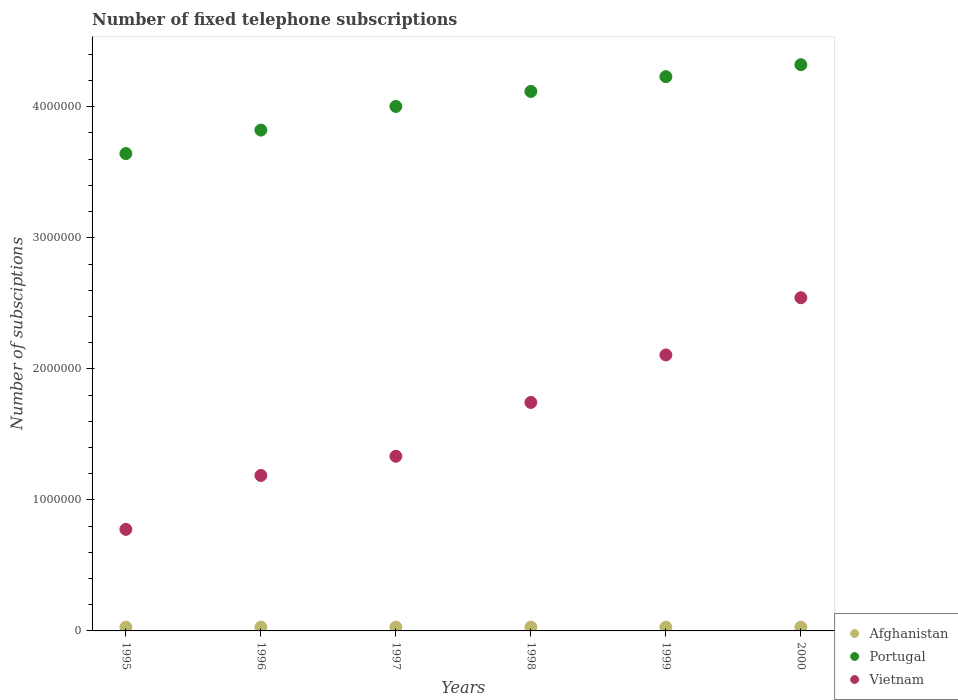How many different coloured dotlines are there?
Ensure brevity in your answer.  3. What is the number of fixed telephone subscriptions in Afghanistan in 1997?
Provide a succinct answer. 2.90e+04. Across all years, what is the maximum number of fixed telephone subscriptions in Vietnam?
Keep it short and to the point. 2.54e+06. Across all years, what is the minimum number of fixed telephone subscriptions in Vietnam?
Provide a short and direct response. 7.75e+05. What is the total number of fixed telephone subscriptions in Portugal in the graph?
Offer a terse response. 2.41e+07. What is the difference between the number of fixed telephone subscriptions in Portugal in 1996 and that in 1999?
Keep it short and to the point. -4.08e+05. What is the difference between the number of fixed telephone subscriptions in Portugal in 1998 and the number of fixed telephone subscriptions in Vietnam in 2000?
Make the answer very short. 1.57e+06. What is the average number of fixed telephone subscriptions in Afghanistan per year?
Provide a short and direct response. 2.90e+04. In the year 1998, what is the difference between the number of fixed telephone subscriptions in Portugal and number of fixed telephone subscriptions in Vietnam?
Ensure brevity in your answer.  2.37e+06. In how many years, is the number of fixed telephone subscriptions in Afghanistan greater than 1800000?
Provide a succinct answer. 0. What is the ratio of the number of fixed telephone subscriptions in Vietnam in 1995 to that in 2000?
Give a very brief answer. 0.3. Is the difference between the number of fixed telephone subscriptions in Portugal in 1998 and 1999 greater than the difference between the number of fixed telephone subscriptions in Vietnam in 1998 and 1999?
Offer a terse response. Yes. What is the difference between the highest and the second highest number of fixed telephone subscriptions in Vietnam?
Your response must be concise. 4.37e+05. What is the difference between the highest and the lowest number of fixed telephone subscriptions in Afghanistan?
Your response must be concise. 0. Is the sum of the number of fixed telephone subscriptions in Afghanistan in 1997 and 2000 greater than the maximum number of fixed telephone subscriptions in Vietnam across all years?
Your answer should be very brief. No. Is it the case that in every year, the sum of the number of fixed telephone subscriptions in Portugal and number of fixed telephone subscriptions in Afghanistan  is greater than the number of fixed telephone subscriptions in Vietnam?
Ensure brevity in your answer.  Yes. Is the number of fixed telephone subscriptions in Afghanistan strictly greater than the number of fixed telephone subscriptions in Vietnam over the years?
Give a very brief answer. No. Is the number of fixed telephone subscriptions in Portugal strictly less than the number of fixed telephone subscriptions in Afghanistan over the years?
Make the answer very short. No. How many years are there in the graph?
Make the answer very short. 6. Does the graph contain any zero values?
Ensure brevity in your answer.  No. Does the graph contain grids?
Your answer should be very brief. No. How many legend labels are there?
Offer a terse response. 3. What is the title of the graph?
Provide a succinct answer. Number of fixed telephone subscriptions. Does "Myanmar" appear as one of the legend labels in the graph?
Offer a very short reply. No. What is the label or title of the Y-axis?
Provide a short and direct response. Number of subsciptions. What is the Number of subsciptions in Afghanistan in 1995?
Your response must be concise. 2.90e+04. What is the Number of subsciptions of Portugal in 1995?
Offer a very short reply. 3.64e+06. What is the Number of subsciptions in Vietnam in 1995?
Ensure brevity in your answer.  7.75e+05. What is the Number of subsciptions in Afghanistan in 1996?
Keep it short and to the point. 2.90e+04. What is the Number of subsciptions in Portugal in 1996?
Offer a terse response. 3.82e+06. What is the Number of subsciptions of Vietnam in 1996?
Your answer should be compact. 1.19e+06. What is the Number of subsciptions in Afghanistan in 1997?
Your response must be concise. 2.90e+04. What is the Number of subsciptions of Portugal in 1997?
Your response must be concise. 4.00e+06. What is the Number of subsciptions in Vietnam in 1997?
Your response must be concise. 1.33e+06. What is the Number of subsciptions in Afghanistan in 1998?
Offer a very short reply. 2.90e+04. What is the Number of subsciptions of Portugal in 1998?
Provide a short and direct response. 4.12e+06. What is the Number of subsciptions in Vietnam in 1998?
Give a very brief answer. 1.74e+06. What is the Number of subsciptions in Afghanistan in 1999?
Your answer should be compact. 2.90e+04. What is the Number of subsciptions of Portugal in 1999?
Offer a terse response. 4.23e+06. What is the Number of subsciptions in Vietnam in 1999?
Provide a succinct answer. 2.11e+06. What is the Number of subsciptions of Afghanistan in 2000?
Your response must be concise. 2.90e+04. What is the Number of subsciptions in Portugal in 2000?
Offer a very short reply. 4.32e+06. What is the Number of subsciptions in Vietnam in 2000?
Give a very brief answer. 2.54e+06. Across all years, what is the maximum Number of subsciptions of Afghanistan?
Provide a short and direct response. 2.90e+04. Across all years, what is the maximum Number of subsciptions of Portugal?
Give a very brief answer. 4.32e+06. Across all years, what is the maximum Number of subsciptions of Vietnam?
Provide a short and direct response. 2.54e+06. Across all years, what is the minimum Number of subsciptions of Afghanistan?
Ensure brevity in your answer.  2.90e+04. Across all years, what is the minimum Number of subsciptions of Portugal?
Your response must be concise. 3.64e+06. Across all years, what is the minimum Number of subsciptions in Vietnam?
Provide a succinct answer. 7.75e+05. What is the total Number of subsciptions in Afghanistan in the graph?
Provide a succinct answer. 1.74e+05. What is the total Number of subsciptions in Portugal in the graph?
Your answer should be compact. 2.41e+07. What is the total Number of subsciptions in Vietnam in the graph?
Give a very brief answer. 9.69e+06. What is the difference between the Number of subsciptions of Portugal in 1995 and that in 1996?
Provide a succinct answer. -1.79e+05. What is the difference between the Number of subsciptions of Vietnam in 1995 and that in 1996?
Offer a terse response. -4.11e+05. What is the difference between the Number of subsciptions in Afghanistan in 1995 and that in 1997?
Your response must be concise. 0. What is the difference between the Number of subsciptions in Portugal in 1995 and that in 1997?
Your answer should be very brief. -3.60e+05. What is the difference between the Number of subsciptions in Vietnam in 1995 and that in 1997?
Your answer should be compact. -5.58e+05. What is the difference between the Number of subsciptions in Portugal in 1995 and that in 1998?
Give a very brief answer. -4.74e+05. What is the difference between the Number of subsciptions of Vietnam in 1995 and that in 1998?
Your answer should be very brief. -9.69e+05. What is the difference between the Number of subsciptions in Portugal in 1995 and that in 1999?
Offer a very short reply. -5.87e+05. What is the difference between the Number of subsciptions of Vietnam in 1995 and that in 1999?
Offer a terse response. -1.33e+06. What is the difference between the Number of subsciptions in Afghanistan in 1995 and that in 2000?
Ensure brevity in your answer.  0. What is the difference between the Number of subsciptions of Portugal in 1995 and that in 2000?
Ensure brevity in your answer.  -6.78e+05. What is the difference between the Number of subsciptions in Vietnam in 1995 and that in 2000?
Provide a short and direct response. -1.77e+06. What is the difference between the Number of subsciptions in Afghanistan in 1996 and that in 1997?
Provide a succinct answer. 0. What is the difference between the Number of subsciptions of Portugal in 1996 and that in 1997?
Ensure brevity in your answer.  -1.81e+05. What is the difference between the Number of subsciptions in Vietnam in 1996 and that in 1997?
Ensure brevity in your answer.  -1.47e+05. What is the difference between the Number of subsciptions of Portugal in 1996 and that in 1998?
Your response must be concise. -2.95e+05. What is the difference between the Number of subsciptions of Vietnam in 1996 and that in 1998?
Provide a short and direct response. -5.57e+05. What is the difference between the Number of subsciptions in Portugal in 1996 and that in 1999?
Keep it short and to the point. -4.08e+05. What is the difference between the Number of subsciptions in Vietnam in 1996 and that in 1999?
Offer a terse response. -9.20e+05. What is the difference between the Number of subsciptions in Portugal in 1996 and that in 2000?
Your answer should be compact. -4.99e+05. What is the difference between the Number of subsciptions in Vietnam in 1996 and that in 2000?
Give a very brief answer. -1.36e+06. What is the difference between the Number of subsciptions of Portugal in 1997 and that in 1998?
Offer a terse response. -1.14e+05. What is the difference between the Number of subsciptions in Vietnam in 1997 and that in 1998?
Keep it short and to the point. -4.11e+05. What is the difference between the Number of subsciptions in Portugal in 1997 and that in 1999?
Make the answer very short. -2.27e+05. What is the difference between the Number of subsciptions of Vietnam in 1997 and that in 1999?
Ensure brevity in your answer.  -7.73e+05. What is the difference between the Number of subsciptions in Afghanistan in 1997 and that in 2000?
Your answer should be very brief. 0. What is the difference between the Number of subsciptions in Portugal in 1997 and that in 2000?
Provide a short and direct response. -3.19e+05. What is the difference between the Number of subsciptions in Vietnam in 1997 and that in 2000?
Provide a short and direct response. -1.21e+06. What is the difference between the Number of subsciptions in Portugal in 1998 and that in 1999?
Ensure brevity in your answer.  -1.13e+05. What is the difference between the Number of subsciptions of Vietnam in 1998 and that in 1999?
Make the answer very short. -3.62e+05. What is the difference between the Number of subsciptions in Portugal in 1998 and that in 2000?
Your response must be concise. -2.04e+05. What is the difference between the Number of subsciptions in Vietnam in 1998 and that in 2000?
Your answer should be very brief. -7.99e+05. What is the difference between the Number of subsciptions of Afghanistan in 1999 and that in 2000?
Provide a succinct answer. 0. What is the difference between the Number of subsciptions in Portugal in 1999 and that in 2000?
Your answer should be compact. -9.12e+04. What is the difference between the Number of subsciptions in Vietnam in 1999 and that in 2000?
Ensure brevity in your answer.  -4.37e+05. What is the difference between the Number of subsciptions in Afghanistan in 1995 and the Number of subsciptions in Portugal in 1996?
Provide a succinct answer. -3.79e+06. What is the difference between the Number of subsciptions in Afghanistan in 1995 and the Number of subsciptions in Vietnam in 1996?
Offer a terse response. -1.16e+06. What is the difference between the Number of subsciptions of Portugal in 1995 and the Number of subsciptions of Vietnam in 1996?
Keep it short and to the point. 2.46e+06. What is the difference between the Number of subsciptions of Afghanistan in 1995 and the Number of subsciptions of Portugal in 1997?
Your answer should be compact. -3.97e+06. What is the difference between the Number of subsciptions in Afghanistan in 1995 and the Number of subsciptions in Vietnam in 1997?
Provide a short and direct response. -1.30e+06. What is the difference between the Number of subsciptions of Portugal in 1995 and the Number of subsciptions of Vietnam in 1997?
Your response must be concise. 2.31e+06. What is the difference between the Number of subsciptions in Afghanistan in 1995 and the Number of subsciptions in Portugal in 1998?
Provide a succinct answer. -4.09e+06. What is the difference between the Number of subsciptions of Afghanistan in 1995 and the Number of subsciptions of Vietnam in 1998?
Give a very brief answer. -1.71e+06. What is the difference between the Number of subsciptions in Portugal in 1995 and the Number of subsciptions in Vietnam in 1998?
Your response must be concise. 1.90e+06. What is the difference between the Number of subsciptions of Afghanistan in 1995 and the Number of subsciptions of Portugal in 1999?
Your answer should be very brief. -4.20e+06. What is the difference between the Number of subsciptions in Afghanistan in 1995 and the Number of subsciptions in Vietnam in 1999?
Provide a short and direct response. -2.08e+06. What is the difference between the Number of subsciptions of Portugal in 1995 and the Number of subsciptions of Vietnam in 1999?
Your answer should be compact. 1.54e+06. What is the difference between the Number of subsciptions of Afghanistan in 1995 and the Number of subsciptions of Portugal in 2000?
Your answer should be very brief. -4.29e+06. What is the difference between the Number of subsciptions in Afghanistan in 1995 and the Number of subsciptions in Vietnam in 2000?
Give a very brief answer. -2.51e+06. What is the difference between the Number of subsciptions of Portugal in 1995 and the Number of subsciptions of Vietnam in 2000?
Make the answer very short. 1.10e+06. What is the difference between the Number of subsciptions of Afghanistan in 1996 and the Number of subsciptions of Portugal in 1997?
Provide a short and direct response. -3.97e+06. What is the difference between the Number of subsciptions in Afghanistan in 1996 and the Number of subsciptions in Vietnam in 1997?
Ensure brevity in your answer.  -1.30e+06. What is the difference between the Number of subsciptions in Portugal in 1996 and the Number of subsciptions in Vietnam in 1997?
Provide a short and direct response. 2.49e+06. What is the difference between the Number of subsciptions of Afghanistan in 1996 and the Number of subsciptions of Portugal in 1998?
Your answer should be compact. -4.09e+06. What is the difference between the Number of subsciptions in Afghanistan in 1996 and the Number of subsciptions in Vietnam in 1998?
Your response must be concise. -1.71e+06. What is the difference between the Number of subsciptions in Portugal in 1996 and the Number of subsciptions in Vietnam in 1998?
Your response must be concise. 2.08e+06. What is the difference between the Number of subsciptions in Afghanistan in 1996 and the Number of subsciptions in Portugal in 1999?
Your response must be concise. -4.20e+06. What is the difference between the Number of subsciptions of Afghanistan in 1996 and the Number of subsciptions of Vietnam in 1999?
Give a very brief answer. -2.08e+06. What is the difference between the Number of subsciptions in Portugal in 1996 and the Number of subsciptions in Vietnam in 1999?
Offer a very short reply. 1.72e+06. What is the difference between the Number of subsciptions of Afghanistan in 1996 and the Number of subsciptions of Portugal in 2000?
Offer a very short reply. -4.29e+06. What is the difference between the Number of subsciptions in Afghanistan in 1996 and the Number of subsciptions in Vietnam in 2000?
Give a very brief answer. -2.51e+06. What is the difference between the Number of subsciptions in Portugal in 1996 and the Number of subsciptions in Vietnam in 2000?
Provide a short and direct response. 1.28e+06. What is the difference between the Number of subsciptions of Afghanistan in 1997 and the Number of subsciptions of Portugal in 1998?
Provide a short and direct response. -4.09e+06. What is the difference between the Number of subsciptions in Afghanistan in 1997 and the Number of subsciptions in Vietnam in 1998?
Offer a terse response. -1.71e+06. What is the difference between the Number of subsciptions of Portugal in 1997 and the Number of subsciptions of Vietnam in 1998?
Make the answer very short. 2.26e+06. What is the difference between the Number of subsciptions in Afghanistan in 1997 and the Number of subsciptions in Portugal in 1999?
Provide a succinct answer. -4.20e+06. What is the difference between the Number of subsciptions in Afghanistan in 1997 and the Number of subsciptions in Vietnam in 1999?
Offer a terse response. -2.08e+06. What is the difference between the Number of subsciptions of Portugal in 1997 and the Number of subsciptions of Vietnam in 1999?
Give a very brief answer. 1.90e+06. What is the difference between the Number of subsciptions of Afghanistan in 1997 and the Number of subsciptions of Portugal in 2000?
Ensure brevity in your answer.  -4.29e+06. What is the difference between the Number of subsciptions in Afghanistan in 1997 and the Number of subsciptions in Vietnam in 2000?
Your response must be concise. -2.51e+06. What is the difference between the Number of subsciptions in Portugal in 1997 and the Number of subsciptions in Vietnam in 2000?
Ensure brevity in your answer.  1.46e+06. What is the difference between the Number of subsciptions in Afghanistan in 1998 and the Number of subsciptions in Portugal in 1999?
Provide a succinct answer. -4.20e+06. What is the difference between the Number of subsciptions of Afghanistan in 1998 and the Number of subsciptions of Vietnam in 1999?
Your answer should be very brief. -2.08e+06. What is the difference between the Number of subsciptions of Portugal in 1998 and the Number of subsciptions of Vietnam in 1999?
Give a very brief answer. 2.01e+06. What is the difference between the Number of subsciptions in Afghanistan in 1998 and the Number of subsciptions in Portugal in 2000?
Give a very brief answer. -4.29e+06. What is the difference between the Number of subsciptions in Afghanistan in 1998 and the Number of subsciptions in Vietnam in 2000?
Keep it short and to the point. -2.51e+06. What is the difference between the Number of subsciptions of Portugal in 1998 and the Number of subsciptions of Vietnam in 2000?
Give a very brief answer. 1.57e+06. What is the difference between the Number of subsciptions in Afghanistan in 1999 and the Number of subsciptions in Portugal in 2000?
Provide a succinct answer. -4.29e+06. What is the difference between the Number of subsciptions of Afghanistan in 1999 and the Number of subsciptions of Vietnam in 2000?
Offer a very short reply. -2.51e+06. What is the difference between the Number of subsciptions of Portugal in 1999 and the Number of subsciptions of Vietnam in 2000?
Your response must be concise. 1.69e+06. What is the average Number of subsciptions of Afghanistan per year?
Provide a short and direct response. 2.90e+04. What is the average Number of subsciptions in Portugal per year?
Your answer should be compact. 4.02e+06. What is the average Number of subsciptions of Vietnam per year?
Make the answer very short. 1.61e+06. In the year 1995, what is the difference between the Number of subsciptions in Afghanistan and Number of subsciptions in Portugal?
Offer a terse response. -3.61e+06. In the year 1995, what is the difference between the Number of subsciptions in Afghanistan and Number of subsciptions in Vietnam?
Provide a succinct answer. -7.46e+05. In the year 1995, what is the difference between the Number of subsciptions in Portugal and Number of subsciptions in Vietnam?
Give a very brief answer. 2.87e+06. In the year 1996, what is the difference between the Number of subsciptions of Afghanistan and Number of subsciptions of Portugal?
Offer a terse response. -3.79e+06. In the year 1996, what is the difference between the Number of subsciptions in Afghanistan and Number of subsciptions in Vietnam?
Provide a succinct answer. -1.16e+06. In the year 1996, what is the difference between the Number of subsciptions of Portugal and Number of subsciptions of Vietnam?
Provide a short and direct response. 2.64e+06. In the year 1997, what is the difference between the Number of subsciptions in Afghanistan and Number of subsciptions in Portugal?
Provide a short and direct response. -3.97e+06. In the year 1997, what is the difference between the Number of subsciptions in Afghanistan and Number of subsciptions in Vietnam?
Your answer should be compact. -1.30e+06. In the year 1997, what is the difference between the Number of subsciptions of Portugal and Number of subsciptions of Vietnam?
Your answer should be compact. 2.67e+06. In the year 1998, what is the difference between the Number of subsciptions in Afghanistan and Number of subsciptions in Portugal?
Make the answer very short. -4.09e+06. In the year 1998, what is the difference between the Number of subsciptions of Afghanistan and Number of subsciptions of Vietnam?
Give a very brief answer. -1.71e+06. In the year 1998, what is the difference between the Number of subsciptions in Portugal and Number of subsciptions in Vietnam?
Your response must be concise. 2.37e+06. In the year 1999, what is the difference between the Number of subsciptions of Afghanistan and Number of subsciptions of Portugal?
Provide a succinct answer. -4.20e+06. In the year 1999, what is the difference between the Number of subsciptions of Afghanistan and Number of subsciptions of Vietnam?
Your answer should be compact. -2.08e+06. In the year 1999, what is the difference between the Number of subsciptions of Portugal and Number of subsciptions of Vietnam?
Provide a succinct answer. 2.12e+06. In the year 2000, what is the difference between the Number of subsciptions in Afghanistan and Number of subsciptions in Portugal?
Your answer should be compact. -4.29e+06. In the year 2000, what is the difference between the Number of subsciptions in Afghanistan and Number of subsciptions in Vietnam?
Your response must be concise. -2.51e+06. In the year 2000, what is the difference between the Number of subsciptions in Portugal and Number of subsciptions in Vietnam?
Offer a very short reply. 1.78e+06. What is the ratio of the Number of subsciptions in Afghanistan in 1995 to that in 1996?
Make the answer very short. 1. What is the ratio of the Number of subsciptions of Portugal in 1995 to that in 1996?
Give a very brief answer. 0.95. What is the ratio of the Number of subsciptions of Vietnam in 1995 to that in 1996?
Your answer should be very brief. 0.65. What is the ratio of the Number of subsciptions of Portugal in 1995 to that in 1997?
Offer a terse response. 0.91. What is the ratio of the Number of subsciptions in Vietnam in 1995 to that in 1997?
Give a very brief answer. 0.58. What is the ratio of the Number of subsciptions of Afghanistan in 1995 to that in 1998?
Make the answer very short. 1. What is the ratio of the Number of subsciptions of Portugal in 1995 to that in 1998?
Provide a short and direct response. 0.88. What is the ratio of the Number of subsciptions in Vietnam in 1995 to that in 1998?
Make the answer very short. 0.44. What is the ratio of the Number of subsciptions of Afghanistan in 1995 to that in 1999?
Offer a terse response. 1. What is the ratio of the Number of subsciptions in Portugal in 1995 to that in 1999?
Provide a succinct answer. 0.86. What is the ratio of the Number of subsciptions of Vietnam in 1995 to that in 1999?
Provide a succinct answer. 0.37. What is the ratio of the Number of subsciptions of Portugal in 1995 to that in 2000?
Keep it short and to the point. 0.84. What is the ratio of the Number of subsciptions in Vietnam in 1995 to that in 2000?
Keep it short and to the point. 0.3. What is the ratio of the Number of subsciptions of Portugal in 1996 to that in 1997?
Your answer should be compact. 0.95. What is the ratio of the Number of subsciptions of Vietnam in 1996 to that in 1997?
Offer a very short reply. 0.89. What is the ratio of the Number of subsciptions in Portugal in 1996 to that in 1998?
Make the answer very short. 0.93. What is the ratio of the Number of subsciptions in Vietnam in 1996 to that in 1998?
Provide a succinct answer. 0.68. What is the ratio of the Number of subsciptions in Afghanistan in 1996 to that in 1999?
Make the answer very short. 1. What is the ratio of the Number of subsciptions of Portugal in 1996 to that in 1999?
Your answer should be very brief. 0.9. What is the ratio of the Number of subsciptions of Vietnam in 1996 to that in 1999?
Provide a succinct answer. 0.56. What is the ratio of the Number of subsciptions in Afghanistan in 1996 to that in 2000?
Make the answer very short. 1. What is the ratio of the Number of subsciptions in Portugal in 1996 to that in 2000?
Make the answer very short. 0.88. What is the ratio of the Number of subsciptions of Vietnam in 1996 to that in 2000?
Your answer should be very brief. 0.47. What is the ratio of the Number of subsciptions in Portugal in 1997 to that in 1998?
Your response must be concise. 0.97. What is the ratio of the Number of subsciptions in Vietnam in 1997 to that in 1998?
Provide a succinct answer. 0.76. What is the ratio of the Number of subsciptions in Portugal in 1997 to that in 1999?
Offer a terse response. 0.95. What is the ratio of the Number of subsciptions of Vietnam in 1997 to that in 1999?
Your answer should be compact. 0.63. What is the ratio of the Number of subsciptions of Afghanistan in 1997 to that in 2000?
Keep it short and to the point. 1. What is the ratio of the Number of subsciptions in Portugal in 1997 to that in 2000?
Offer a very short reply. 0.93. What is the ratio of the Number of subsciptions in Vietnam in 1997 to that in 2000?
Your response must be concise. 0.52. What is the ratio of the Number of subsciptions of Portugal in 1998 to that in 1999?
Provide a succinct answer. 0.97. What is the ratio of the Number of subsciptions of Vietnam in 1998 to that in 1999?
Provide a succinct answer. 0.83. What is the ratio of the Number of subsciptions in Afghanistan in 1998 to that in 2000?
Give a very brief answer. 1. What is the ratio of the Number of subsciptions of Portugal in 1998 to that in 2000?
Give a very brief answer. 0.95. What is the ratio of the Number of subsciptions in Vietnam in 1998 to that in 2000?
Make the answer very short. 0.69. What is the ratio of the Number of subsciptions in Afghanistan in 1999 to that in 2000?
Provide a succinct answer. 1. What is the ratio of the Number of subsciptions of Portugal in 1999 to that in 2000?
Your answer should be very brief. 0.98. What is the ratio of the Number of subsciptions in Vietnam in 1999 to that in 2000?
Your response must be concise. 0.83. What is the difference between the highest and the second highest Number of subsciptions of Afghanistan?
Your answer should be very brief. 0. What is the difference between the highest and the second highest Number of subsciptions in Portugal?
Provide a short and direct response. 9.12e+04. What is the difference between the highest and the second highest Number of subsciptions of Vietnam?
Keep it short and to the point. 4.37e+05. What is the difference between the highest and the lowest Number of subsciptions of Afghanistan?
Provide a succinct answer. 0. What is the difference between the highest and the lowest Number of subsciptions of Portugal?
Give a very brief answer. 6.78e+05. What is the difference between the highest and the lowest Number of subsciptions of Vietnam?
Offer a very short reply. 1.77e+06. 